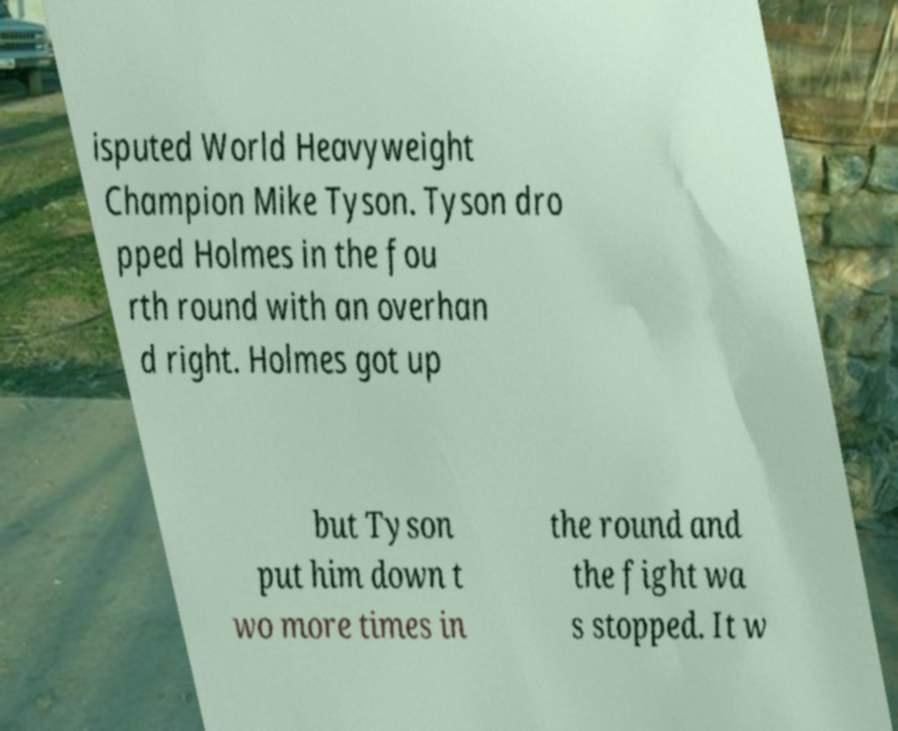Could you assist in decoding the text presented in this image and type it out clearly? isputed World Heavyweight Champion Mike Tyson. Tyson dro pped Holmes in the fou rth round with an overhan d right. Holmes got up but Tyson put him down t wo more times in the round and the fight wa s stopped. It w 